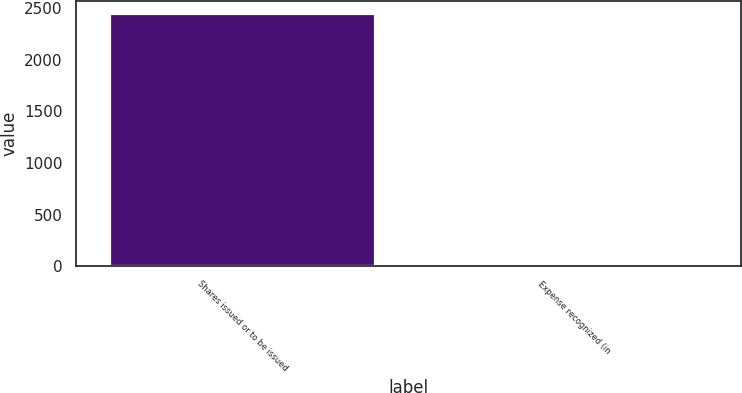Convert chart to OTSL. <chart><loc_0><loc_0><loc_500><loc_500><bar_chart><fcel>Shares issued or to be issued<fcel>Expense recognized (in<nl><fcel>2452<fcel>17<nl></chart> 